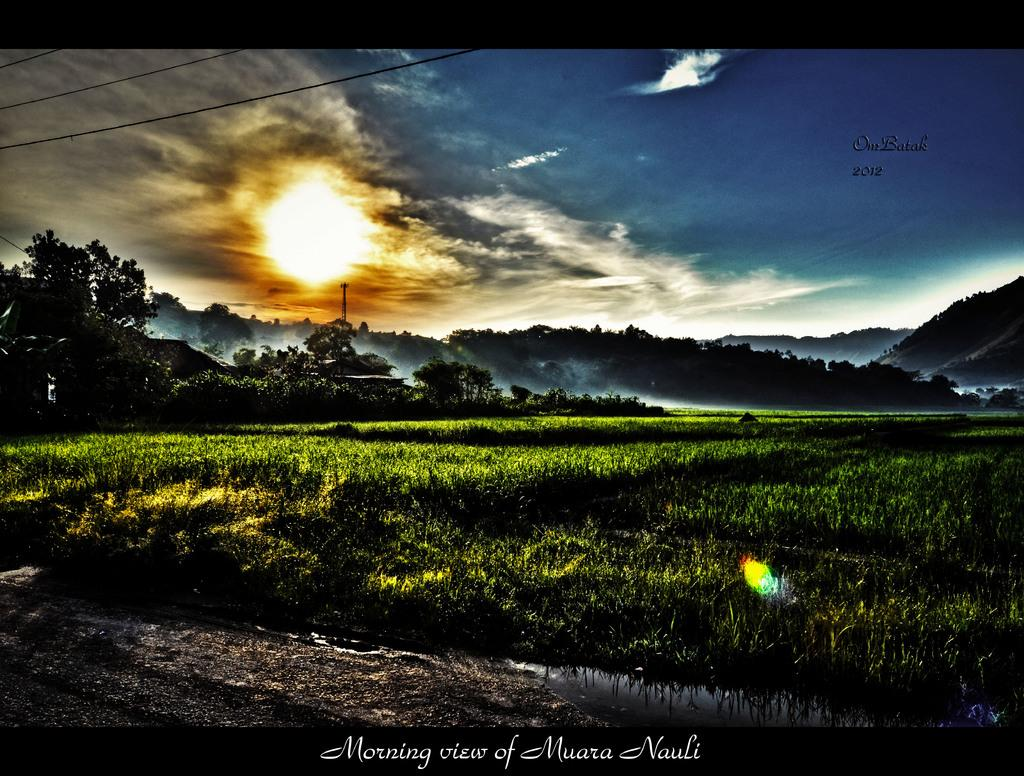What type of landscape is depicted in the image? There is a farm field in the image. What natural feature can be seen in the image? There is water visible in the image. What can be seen in the distance in the image? There are hills in the background of the image. What type of vegetation is present in the image? There are trees in the image. What is visible in the sky in the image? There are clouds in the sky in the image. What type of advertisement can be seen on the farm field in the image? There is no advertisement present on the farm field in the image. What color is the nose of the cow in the image? There are no cows present in the image, so it is not possible to determine the color of a cow's nose. 